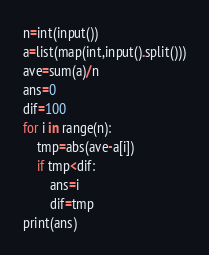Convert code to text. <code><loc_0><loc_0><loc_500><loc_500><_Python_>n=int(input())
a=list(map(int,input().split()))
ave=sum(a)/n
ans=0
dif=100
for i in range(n):
    tmp=abs(ave-a[i])
    if tmp<dif:
        ans=i
        dif=tmp
print(ans)</code> 